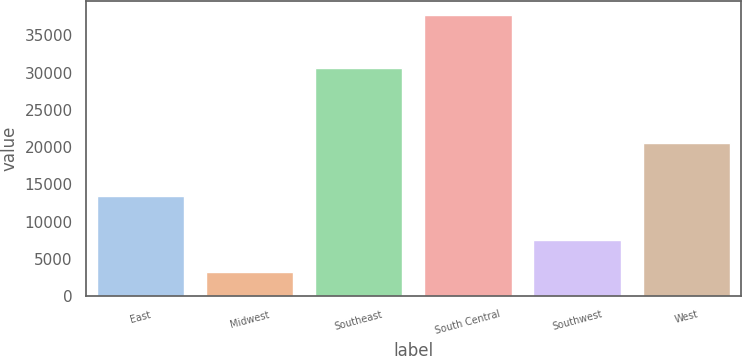<chart> <loc_0><loc_0><loc_500><loc_500><bar_chart><fcel>East<fcel>Midwest<fcel>Southeast<fcel>South Central<fcel>Southwest<fcel>West<nl><fcel>13400<fcel>3200<fcel>30600<fcel>37700<fcel>7500<fcel>20500<nl></chart> 